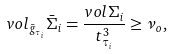<formula> <loc_0><loc_0><loc_500><loc_500>v o l _ { \bar { g } _ { \tau _ { i } } } \bar { \Sigma } _ { i } = \frac { v o l \Sigma _ { i } } { t _ { \tau _ { i } } ^ { 3 } } \geq \nu _ { o } ,</formula> 